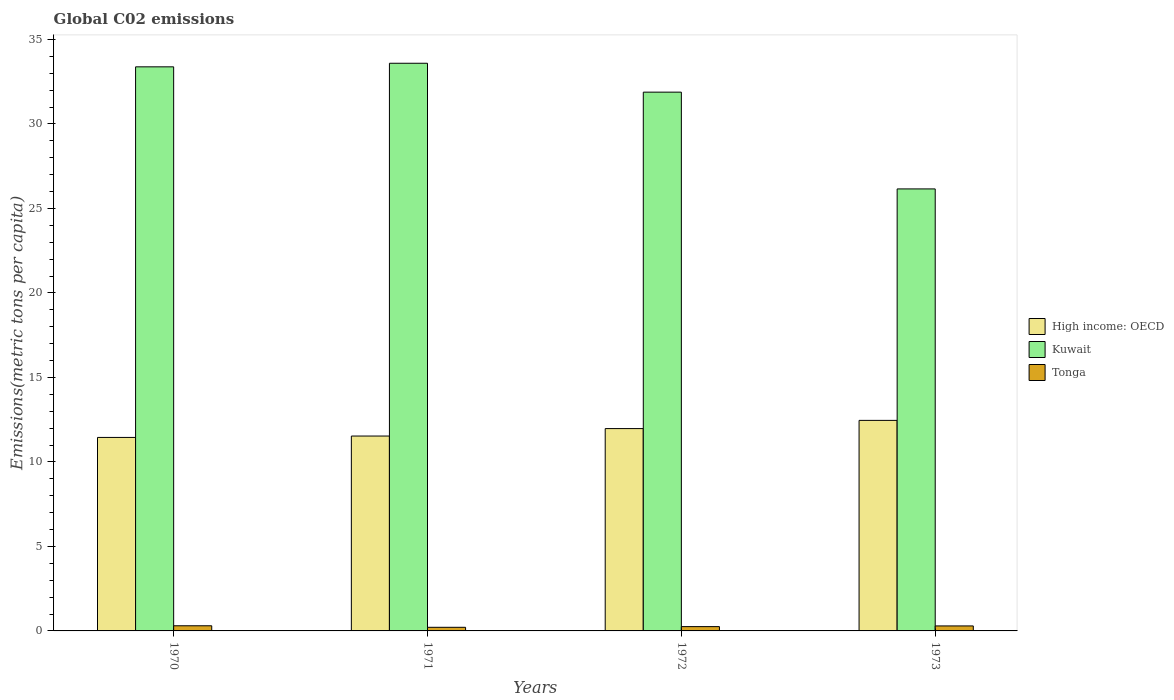Are the number of bars per tick equal to the number of legend labels?
Give a very brief answer. Yes. Are the number of bars on each tick of the X-axis equal?
Your answer should be very brief. Yes. How many bars are there on the 4th tick from the right?
Your response must be concise. 3. In how many cases, is the number of bars for a given year not equal to the number of legend labels?
Keep it short and to the point. 0. What is the amount of CO2 emitted in in High income: OECD in 1971?
Your answer should be very brief. 11.53. Across all years, what is the maximum amount of CO2 emitted in in Kuwait?
Your answer should be compact. 33.59. Across all years, what is the minimum amount of CO2 emitted in in High income: OECD?
Your response must be concise. 11.45. What is the total amount of CO2 emitted in in Kuwait in the graph?
Keep it short and to the point. 125.01. What is the difference between the amount of CO2 emitted in in Kuwait in 1970 and that in 1971?
Keep it short and to the point. -0.21. What is the difference between the amount of CO2 emitted in in Kuwait in 1972 and the amount of CO2 emitted in in Tonga in 1971?
Offer a very short reply. 31.67. What is the average amount of CO2 emitted in in Kuwait per year?
Provide a succinct answer. 31.25. In the year 1973, what is the difference between the amount of CO2 emitted in in Tonga and amount of CO2 emitted in in Kuwait?
Provide a succinct answer. -25.86. In how many years, is the amount of CO2 emitted in in High income: OECD greater than 28 metric tons per capita?
Your answer should be very brief. 0. What is the ratio of the amount of CO2 emitted in in Kuwait in 1970 to that in 1973?
Your answer should be very brief. 1.28. Is the difference between the amount of CO2 emitted in in Tonga in 1972 and 1973 greater than the difference between the amount of CO2 emitted in in Kuwait in 1972 and 1973?
Give a very brief answer. No. What is the difference between the highest and the second highest amount of CO2 emitted in in High income: OECD?
Offer a terse response. 0.49. What is the difference between the highest and the lowest amount of CO2 emitted in in Tonga?
Make the answer very short. 0.09. In how many years, is the amount of CO2 emitted in in High income: OECD greater than the average amount of CO2 emitted in in High income: OECD taken over all years?
Keep it short and to the point. 2. What does the 2nd bar from the left in 1972 represents?
Make the answer very short. Kuwait. What does the 3rd bar from the right in 1973 represents?
Make the answer very short. High income: OECD. Is it the case that in every year, the sum of the amount of CO2 emitted in in High income: OECD and amount of CO2 emitted in in Kuwait is greater than the amount of CO2 emitted in in Tonga?
Offer a very short reply. Yes. How many bars are there?
Ensure brevity in your answer.  12. Are the values on the major ticks of Y-axis written in scientific E-notation?
Your answer should be compact. No. Does the graph contain any zero values?
Your answer should be compact. No. Does the graph contain grids?
Give a very brief answer. No. How are the legend labels stacked?
Your answer should be compact. Vertical. What is the title of the graph?
Ensure brevity in your answer.  Global C02 emissions. What is the label or title of the Y-axis?
Make the answer very short. Emissions(metric tons per capita). What is the Emissions(metric tons per capita) of High income: OECD in 1970?
Offer a very short reply. 11.45. What is the Emissions(metric tons per capita) of Kuwait in 1970?
Your answer should be compact. 33.38. What is the Emissions(metric tons per capita) of Tonga in 1970?
Your answer should be very brief. 0.3. What is the Emissions(metric tons per capita) of High income: OECD in 1971?
Offer a terse response. 11.53. What is the Emissions(metric tons per capita) of Kuwait in 1971?
Your answer should be very brief. 33.59. What is the Emissions(metric tons per capita) of Tonga in 1971?
Keep it short and to the point. 0.21. What is the Emissions(metric tons per capita) of High income: OECD in 1972?
Your response must be concise. 11.97. What is the Emissions(metric tons per capita) of Kuwait in 1972?
Your response must be concise. 31.88. What is the Emissions(metric tons per capita) in Tonga in 1972?
Provide a short and direct response. 0.25. What is the Emissions(metric tons per capita) in High income: OECD in 1973?
Offer a terse response. 12.46. What is the Emissions(metric tons per capita) in Kuwait in 1973?
Give a very brief answer. 26.16. What is the Emissions(metric tons per capita) in Tonga in 1973?
Make the answer very short. 0.3. Across all years, what is the maximum Emissions(metric tons per capita) of High income: OECD?
Your response must be concise. 12.46. Across all years, what is the maximum Emissions(metric tons per capita) of Kuwait?
Ensure brevity in your answer.  33.59. Across all years, what is the maximum Emissions(metric tons per capita) of Tonga?
Your response must be concise. 0.3. Across all years, what is the minimum Emissions(metric tons per capita) in High income: OECD?
Give a very brief answer. 11.45. Across all years, what is the minimum Emissions(metric tons per capita) in Kuwait?
Keep it short and to the point. 26.16. Across all years, what is the minimum Emissions(metric tons per capita) in Tonga?
Your answer should be compact. 0.21. What is the total Emissions(metric tons per capita) in High income: OECD in the graph?
Make the answer very short. 47.42. What is the total Emissions(metric tons per capita) of Kuwait in the graph?
Give a very brief answer. 125.01. What is the total Emissions(metric tons per capita) in Tonga in the graph?
Provide a succinct answer. 1.07. What is the difference between the Emissions(metric tons per capita) of High income: OECD in 1970 and that in 1971?
Ensure brevity in your answer.  -0.08. What is the difference between the Emissions(metric tons per capita) in Kuwait in 1970 and that in 1971?
Ensure brevity in your answer.  -0.21. What is the difference between the Emissions(metric tons per capita) of Tonga in 1970 and that in 1971?
Provide a succinct answer. 0.09. What is the difference between the Emissions(metric tons per capita) in High income: OECD in 1970 and that in 1972?
Provide a succinct answer. -0.52. What is the difference between the Emissions(metric tons per capita) in Kuwait in 1970 and that in 1972?
Provide a succinct answer. 1.5. What is the difference between the Emissions(metric tons per capita) in Tonga in 1970 and that in 1972?
Provide a succinct answer. 0.05. What is the difference between the Emissions(metric tons per capita) in High income: OECD in 1970 and that in 1973?
Provide a succinct answer. -1.01. What is the difference between the Emissions(metric tons per capita) of Kuwait in 1970 and that in 1973?
Offer a terse response. 7.22. What is the difference between the Emissions(metric tons per capita) in Tonga in 1970 and that in 1973?
Offer a very short reply. 0.01. What is the difference between the Emissions(metric tons per capita) in High income: OECD in 1971 and that in 1972?
Make the answer very short. -0.44. What is the difference between the Emissions(metric tons per capita) of Kuwait in 1971 and that in 1972?
Your response must be concise. 1.71. What is the difference between the Emissions(metric tons per capita) of Tonga in 1971 and that in 1972?
Give a very brief answer. -0.04. What is the difference between the Emissions(metric tons per capita) in High income: OECD in 1971 and that in 1973?
Keep it short and to the point. -0.93. What is the difference between the Emissions(metric tons per capita) of Kuwait in 1971 and that in 1973?
Provide a succinct answer. 7.44. What is the difference between the Emissions(metric tons per capita) of Tonga in 1971 and that in 1973?
Keep it short and to the point. -0.08. What is the difference between the Emissions(metric tons per capita) of High income: OECD in 1972 and that in 1973?
Provide a short and direct response. -0.49. What is the difference between the Emissions(metric tons per capita) of Kuwait in 1972 and that in 1973?
Ensure brevity in your answer.  5.73. What is the difference between the Emissions(metric tons per capita) in Tonga in 1972 and that in 1973?
Make the answer very short. -0.04. What is the difference between the Emissions(metric tons per capita) in High income: OECD in 1970 and the Emissions(metric tons per capita) in Kuwait in 1971?
Make the answer very short. -22.14. What is the difference between the Emissions(metric tons per capita) of High income: OECD in 1970 and the Emissions(metric tons per capita) of Tonga in 1971?
Your response must be concise. 11.24. What is the difference between the Emissions(metric tons per capita) in Kuwait in 1970 and the Emissions(metric tons per capita) in Tonga in 1971?
Give a very brief answer. 33.17. What is the difference between the Emissions(metric tons per capita) of High income: OECD in 1970 and the Emissions(metric tons per capita) of Kuwait in 1972?
Provide a succinct answer. -20.43. What is the difference between the Emissions(metric tons per capita) in High income: OECD in 1970 and the Emissions(metric tons per capita) in Tonga in 1972?
Your answer should be compact. 11.2. What is the difference between the Emissions(metric tons per capita) of Kuwait in 1970 and the Emissions(metric tons per capita) of Tonga in 1972?
Your response must be concise. 33.13. What is the difference between the Emissions(metric tons per capita) in High income: OECD in 1970 and the Emissions(metric tons per capita) in Kuwait in 1973?
Your answer should be compact. -14.71. What is the difference between the Emissions(metric tons per capita) in High income: OECD in 1970 and the Emissions(metric tons per capita) in Tonga in 1973?
Provide a succinct answer. 11.16. What is the difference between the Emissions(metric tons per capita) of Kuwait in 1970 and the Emissions(metric tons per capita) of Tonga in 1973?
Provide a succinct answer. 33.09. What is the difference between the Emissions(metric tons per capita) of High income: OECD in 1971 and the Emissions(metric tons per capita) of Kuwait in 1972?
Offer a terse response. -20.35. What is the difference between the Emissions(metric tons per capita) in High income: OECD in 1971 and the Emissions(metric tons per capita) in Tonga in 1972?
Your answer should be very brief. 11.28. What is the difference between the Emissions(metric tons per capita) of Kuwait in 1971 and the Emissions(metric tons per capita) of Tonga in 1972?
Your answer should be compact. 33.34. What is the difference between the Emissions(metric tons per capita) of High income: OECD in 1971 and the Emissions(metric tons per capita) of Kuwait in 1973?
Your answer should be very brief. -14.62. What is the difference between the Emissions(metric tons per capita) of High income: OECD in 1971 and the Emissions(metric tons per capita) of Tonga in 1973?
Provide a short and direct response. 11.24. What is the difference between the Emissions(metric tons per capita) of Kuwait in 1971 and the Emissions(metric tons per capita) of Tonga in 1973?
Your answer should be very brief. 33.3. What is the difference between the Emissions(metric tons per capita) in High income: OECD in 1972 and the Emissions(metric tons per capita) in Kuwait in 1973?
Your answer should be very brief. -14.18. What is the difference between the Emissions(metric tons per capita) in High income: OECD in 1972 and the Emissions(metric tons per capita) in Tonga in 1973?
Offer a very short reply. 11.68. What is the difference between the Emissions(metric tons per capita) in Kuwait in 1972 and the Emissions(metric tons per capita) in Tonga in 1973?
Give a very brief answer. 31.59. What is the average Emissions(metric tons per capita) of High income: OECD per year?
Give a very brief answer. 11.85. What is the average Emissions(metric tons per capita) in Kuwait per year?
Give a very brief answer. 31.25. What is the average Emissions(metric tons per capita) of Tonga per year?
Give a very brief answer. 0.27. In the year 1970, what is the difference between the Emissions(metric tons per capita) of High income: OECD and Emissions(metric tons per capita) of Kuwait?
Your answer should be compact. -21.93. In the year 1970, what is the difference between the Emissions(metric tons per capita) in High income: OECD and Emissions(metric tons per capita) in Tonga?
Your answer should be compact. 11.15. In the year 1970, what is the difference between the Emissions(metric tons per capita) in Kuwait and Emissions(metric tons per capita) in Tonga?
Provide a short and direct response. 33.08. In the year 1971, what is the difference between the Emissions(metric tons per capita) of High income: OECD and Emissions(metric tons per capita) of Kuwait?
Your answer should be compact. -22.06. In the year 1971, what is the difference between the Emissions(metric tons per capita) of High income: OECD and Emissions(metric tons per capita) of Tonga?
Your response must be concise. 11.32. In the year 1971, what is the difference between the Emissions(metric tons per capita) in Kuwait and Emissions(metric tons per capita) in Tonga?
Offer a terse response. 33.38. In the year 1972, what is the difference between the Emissions(metric tons per capita) of High income: OECD and Emissions(metric tons per capita) of Kuwait?
Provide a succinct answer. -19.91. In the year 1972, what is the difference between the Emissions(metric tons per capita) in High income: OECD and Emissions(metric tons per capita) in Tonga?
Ensure brevity in your answer.  11.72. In the year 1972, what is the difference between the Emissions(metric tons per capita) in Kuwait and Emissions(metric tons per capita) in Tonga?
Keep it short and to the point. 31.63. In the year 1973, what is the difference between the Emissions(metric tons per capita) of High income: OECD and Emissions(metric tons per capita) of Kuwait?
Ensure brevity in your answer.  -13.7. In the year 1973, what is the difference between the Emissions(metric tons per capita) in High income: OECD and Emissions(metric tons per capita) in Tonga?
Keep it short and to the point. 12.16. In the year 1973, what is the difference between the Emissions(metric tons per capita) in Kuwait and Emissions(metric tons per capita) in Tonga?
Make the answer very short. 25.86. What is the ratio of the Emissions(metric tons per capita) in High income: OECD in 1970 to that in 1971?
Give a very brief answer. 0.99. What is the ratio of the Emissions(metric tons per capita) in Tonga in 1970 to that in 1971?
Keep it short and to the point. 1.42. What is the ratio of the Emissions(metric tons per capita) of High income: OECD in 1970 to that in 1972?
Your response must be concise. 0.96. What is the ratio of the Emissions(metric tons per capita) of Kuwait in 1970 to that in 1972?
Your answer should be compact. 1.05. What is the ratio of the Emissions(metric tons per capita) of Tonga in 1970 to that in 1972?
Keep it short and to the point. 1.19. What is the ratio of the Emissions(metric tons per capita) of High income: OECD in 1970 to that in 1973?
Provide a short and direct response. 0.92. What is the ratio of the Emissions(metric tons per capita) of Kuwait in 1970 to that in 1973?
Provide a succinct answer. 1.28. What is the ratio of the Emissions(metric tons per capita) of Tonga in 1970 to that in 1973?
Offer a very short reply. 1.03. What is the ratio of the Emissions(metric tons per capita) in High income: OECD in 1971 to that in 1972?
Your response must be concise. 0.96. What is the ratio of the Emissions(metric tons per capita) in Kuwait in 1971 to that in 1972?
Your answer should be compact. 1.05. What is the ratio of the Emissions(metric tons per capita) in Tonga in 1971 to that in 1972?
Offer a very short reply. 0.84. What is the ratio of the Emissions(metric tons per capita) of High income: OECD in 1971 to that in 1973?
Keep it short and to the point. 0.93. What is the ratio of the Emissions(metric tons per capita) of Kuwait in 1971 to that in 1973?
Provide a short and direct response. 1.28. What is the ratio of the Emissions(metric tons per capita) of Tonga in 1971 to that in 1973?
Provide a short and direct response. 0.73. What is the ratio of the Emissions(metric tons per capita) of High income: OECD in 1972 to that in 1973?
Provide a succinct answer. 0.96. What is the ratio of the Emissions(metric tons per capita) of Kuwait in 1972 to that in 1973?
Make the answer very short. 1.22. What is the ratio of the Emissions(metric tons per capita) in Tonga in 1972 to that in 1973?
Provide a short and direct response. 0.86. What is the difference between the highest and the second highest Emissions(metric tons per capita) of High income: OECD?
Provide a succinct answer. 0.49. What is the difference between the highest and the second highest Emissions(metric tons per capita) in Kuwait?
Provide a succinct answer. 0.21. What is the difference between the highest and the second highest Emissions(metric tons per capita) of Tonga?
Ensure brevity in your answer.  0.01. What is the difference between the highest and the lowest Emissions(metric tons per capita) in High income: OECD?
Your answer should be very brief. 1.01. What is the difference between the highest and the lowest Emissions(metric tons per capita) in Kuwait?
Provide a short and direct response. 7.44. What is the difference between the highest and the lowest Emissions(metric tons per capita) of Tonga?
Your answer should be compact. 0.09. 